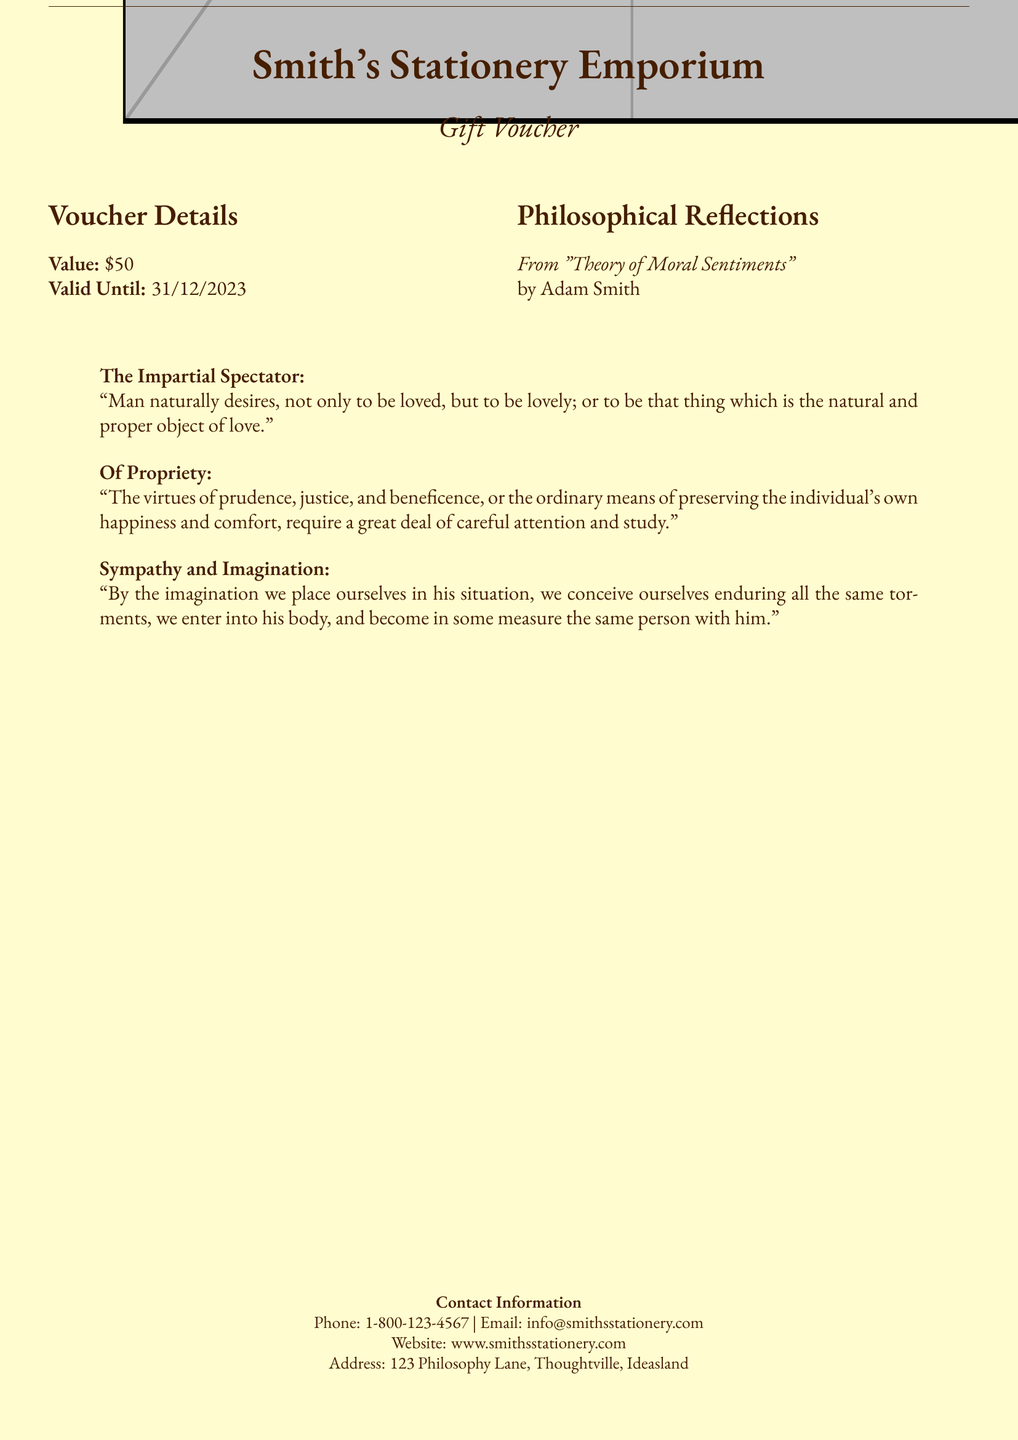What is the value of the gift voucher? The document specifies the monetary value assigned to the voucher as stated in the "Voucher Details" section.
Answer: $50 When is the voucher valid until? The document provides an expiration date for the voucher, which is indicated under "Voucher Details."
Answer: 31/12/2023 Who is the author of the philosophical excerpts? The document attributes the excerpts presented in the voucher to a well-known philosopher, which is mentioned at the beginning of the "Philosophical Reflections" section.
Answer: Adam Smith What is the name of the stationery store? The title at the top of the document indicates the name of the store offering the voucher.
Answer: Smith's Stationery Emporium What is one of the virtues mentioned in the document? The document cites specific virtues that are discussed in the third quote under "Philosophical Reflections."
Answer: Prudence How does the voucher reflect a philosophical theme? The document incorporates excerpts from a philosophical work, suggesting a connection between the store's offerings and deeper reflective thoughts, which is noted in the "Philosophical Reflections" section.
Answer: Through philosophical excerpts What is the phone number for the stationery store? The document lists a contact number for inquiries, which is found in the "Contact Information" section.
Answer: 1-800-123-4567 What city is listed in the contact information? The document details the address of the store in the "Contact Information" section.
Answer: Thoughtville How many quotes are provided in the document? The number of quotes can be counted from their presentation within the document.
Answer: Three 